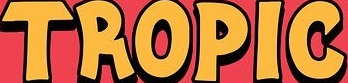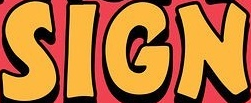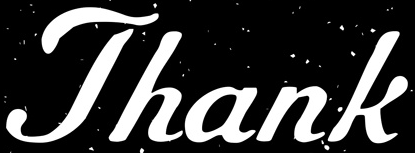What words can you see in these images in sequence, separated by a semicolon? TROPIC; SIGN; Thank 